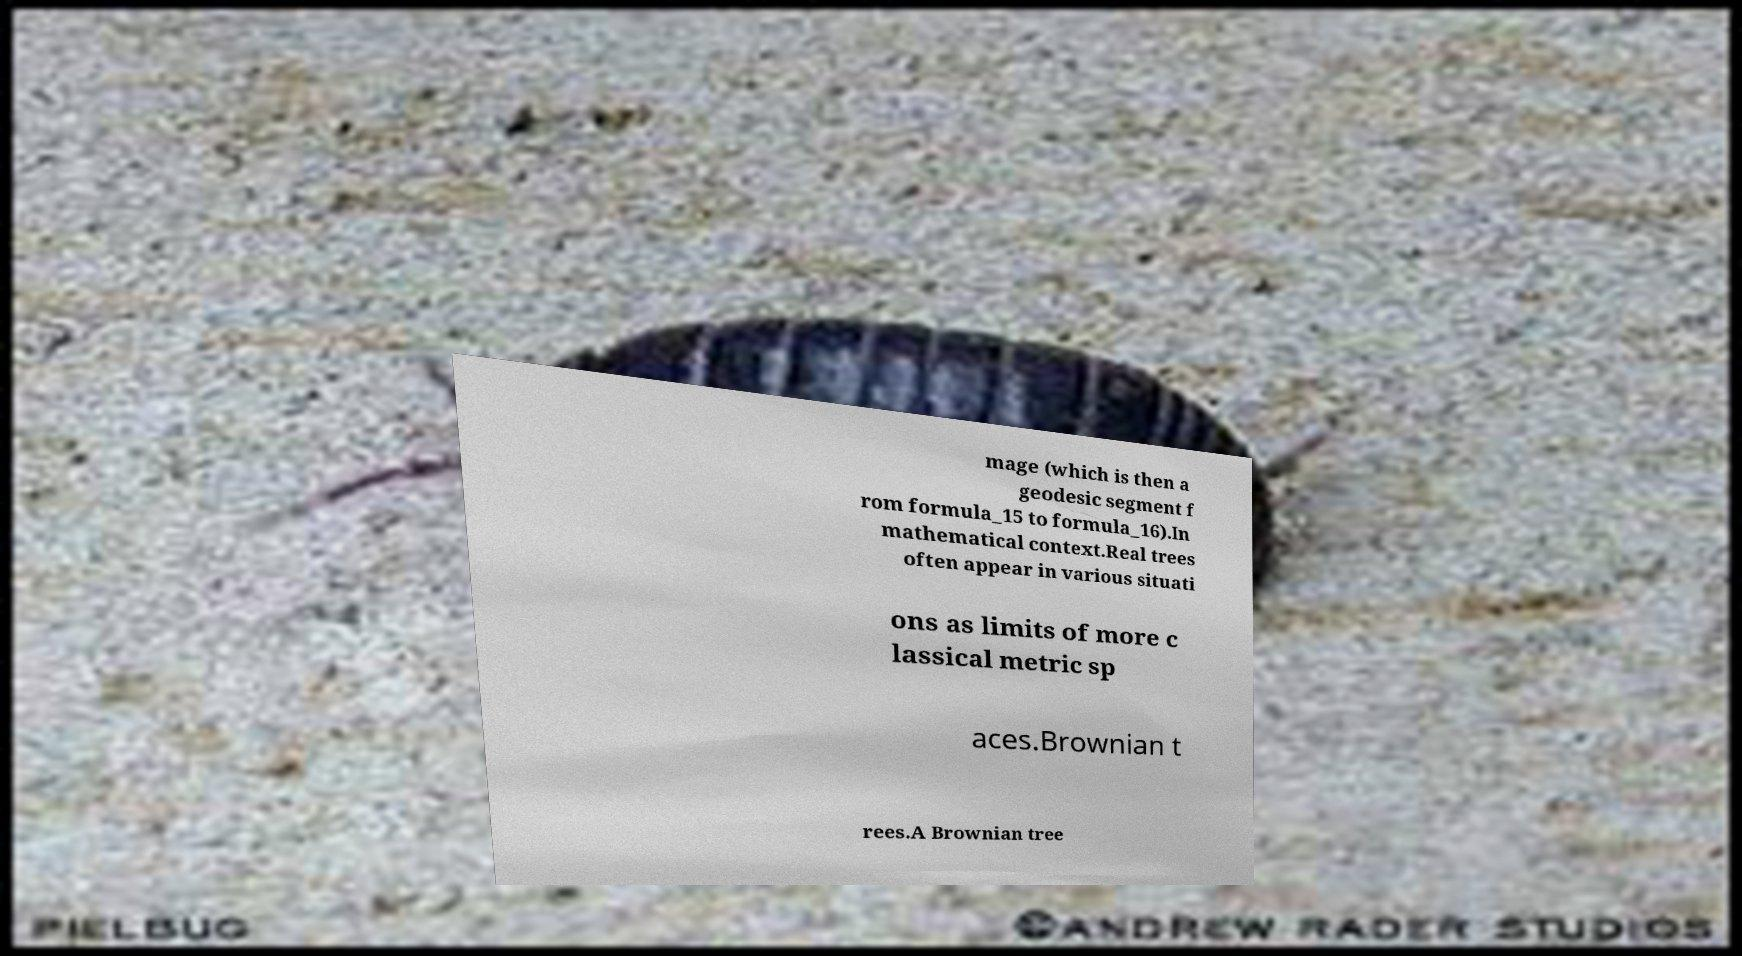Please read and relay the text visible in this image. What does it say? mage (which is then a geodesic segment f rom formula_15 to formula_16).In mathematical context.Real trees often appear in various situati ons as limits of more c lassical metric sp aces.Brownian t rees.A Brownian tree 